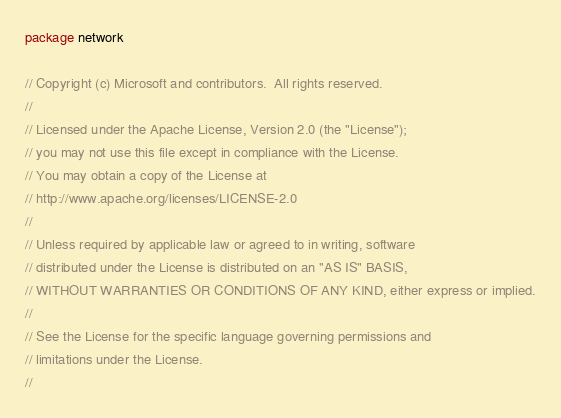Convert code to text. <code><loc_0><loc_0><loc_500><loc_500><_Go_>package network

// Copyright (c) Microsoft and contributors.  All rights reserved.
//
// Licensed under the Apache License, Version 2.0 (the "License");
// you may not use this file except in compliance with the License.
// You may obtain a copy of the License at
// http://www.apache.org/licenses/LICENSE-2.0
//
// Unless required by applicable law or agreed to in writing, software
// distributed under the License is distributed on an "AS IS" BASIS,
// WITHOUT WARRANTIES OR CONDITIONS OF ANY KIND, either express or implied.
//
// See the License for the specific language governing permissions and
// limitations under the License.
//</code> 